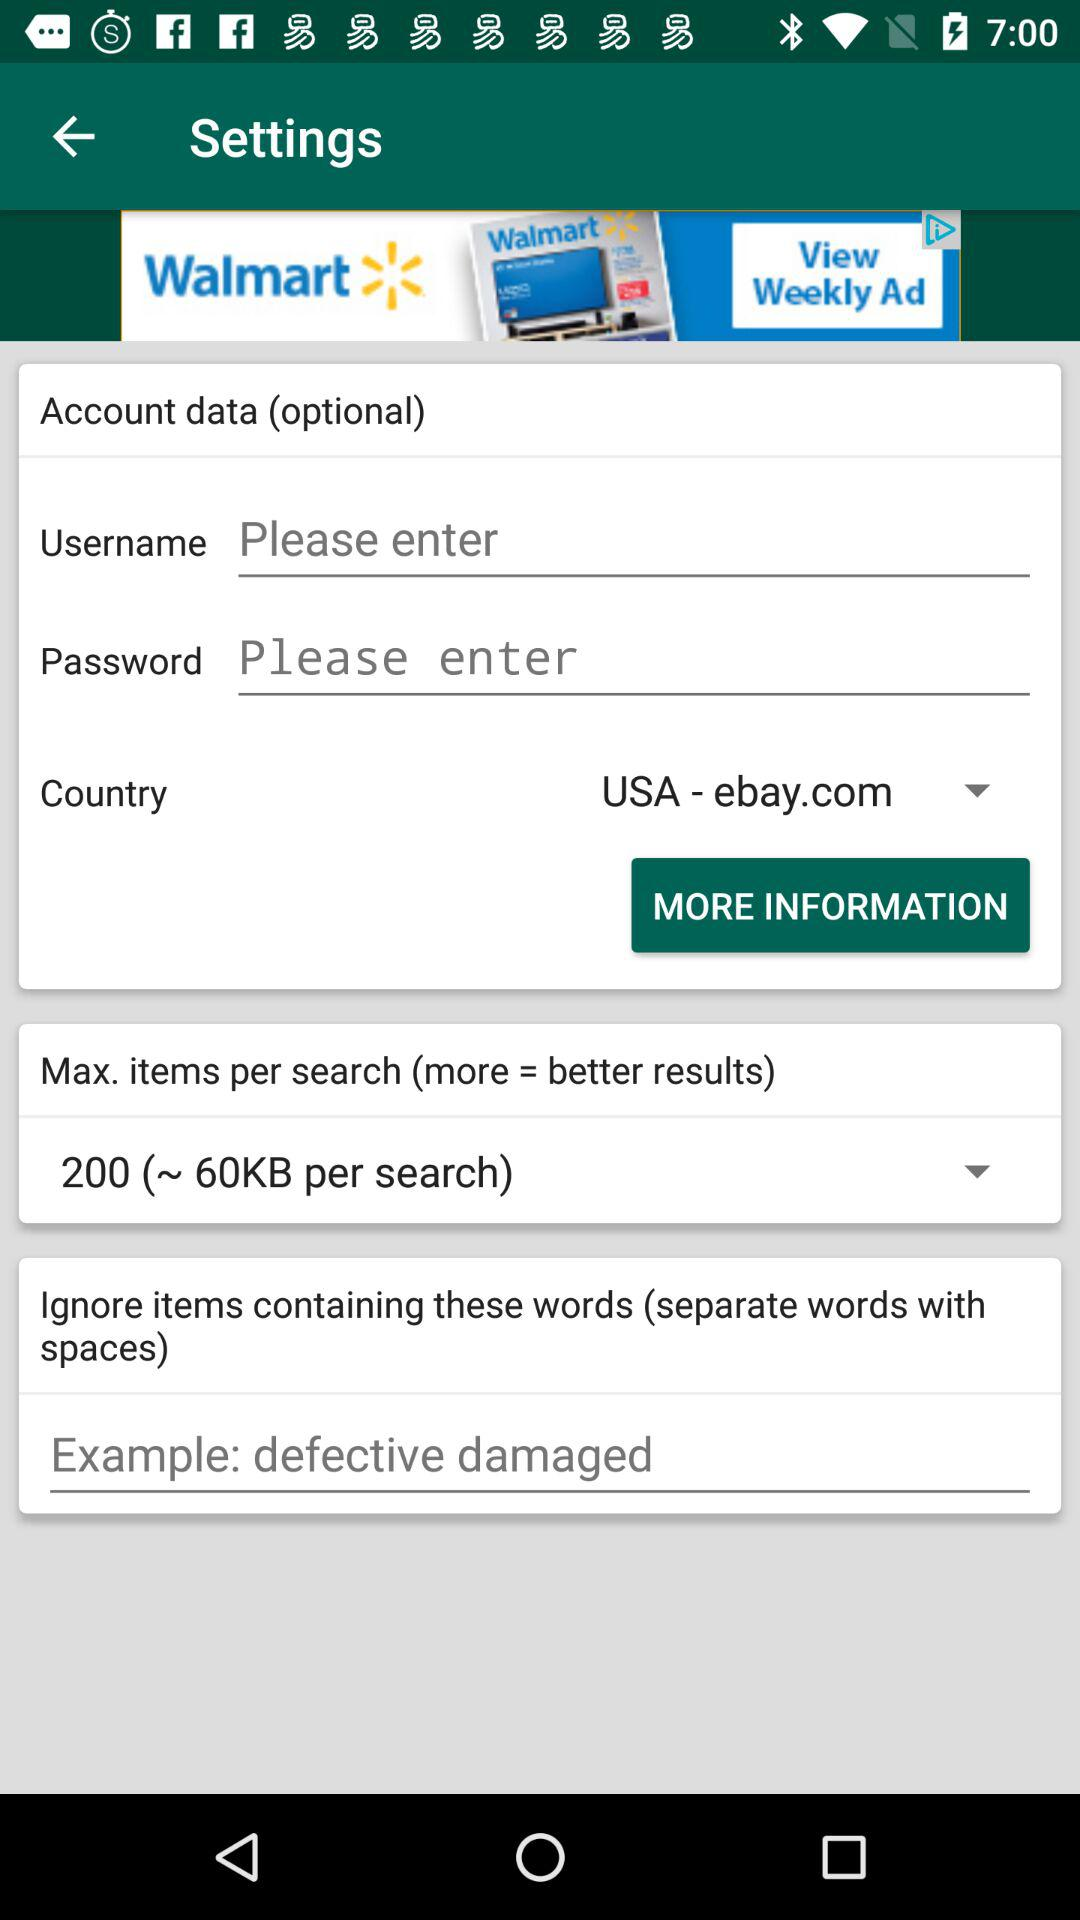What is the country name? The country name is the USA. 